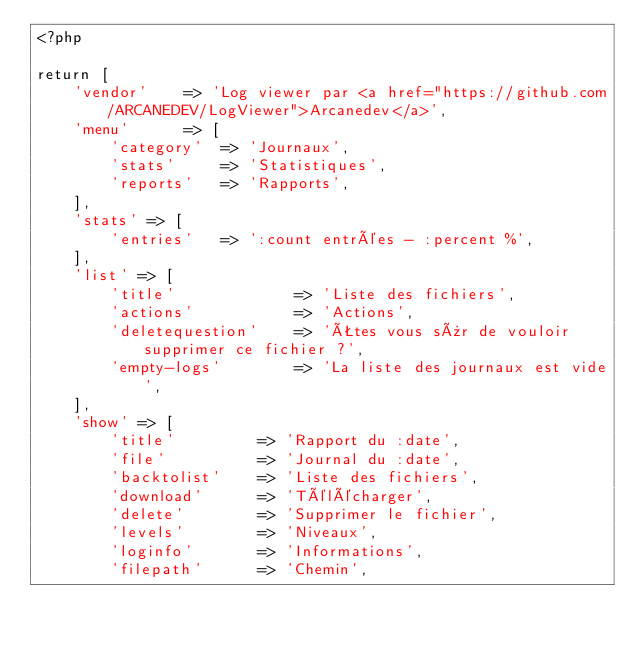Convert code to text. <code><loc_0><loc_0><loc_500><loc_500><_PHP_><?php

return [
    'vendor'    => 'Log viewer par <a href="https://github.com/ARCANEDEV/LogViewer">Arcanedev</a>',
    'menu'      => [
        'category'  => 'Journaux',
        'stats'     => 'Statistiques',
        'reports'   => 'Rapports',
    ],
    'stats' => [
        'entries'   => ':count entrées - :percent %',
    ],
    'list' => [
        'title'             => 'Liste des fichiers',
        'actions'           => 'Actions',
        'deletequestion'    => 'Êtes vous sûr de vouloir supprimer ce fichier ?',
        'empty-logs'        => 'La liste des journaux est vide',
    ],
    'show' => [
        'title'         => 'Rapport du :date',
        'file'          => 'Journal du :date',
        'backtolist'    => 'Liste des fichiers',
        'download'      => 'Télécharger',
        'delete'        => 'Supprimer le fichier',
        'levels'        => 'Niveaux',
        'loginfo'       => 'Informations',
        'filepath'      => 'Chemin',</code> 